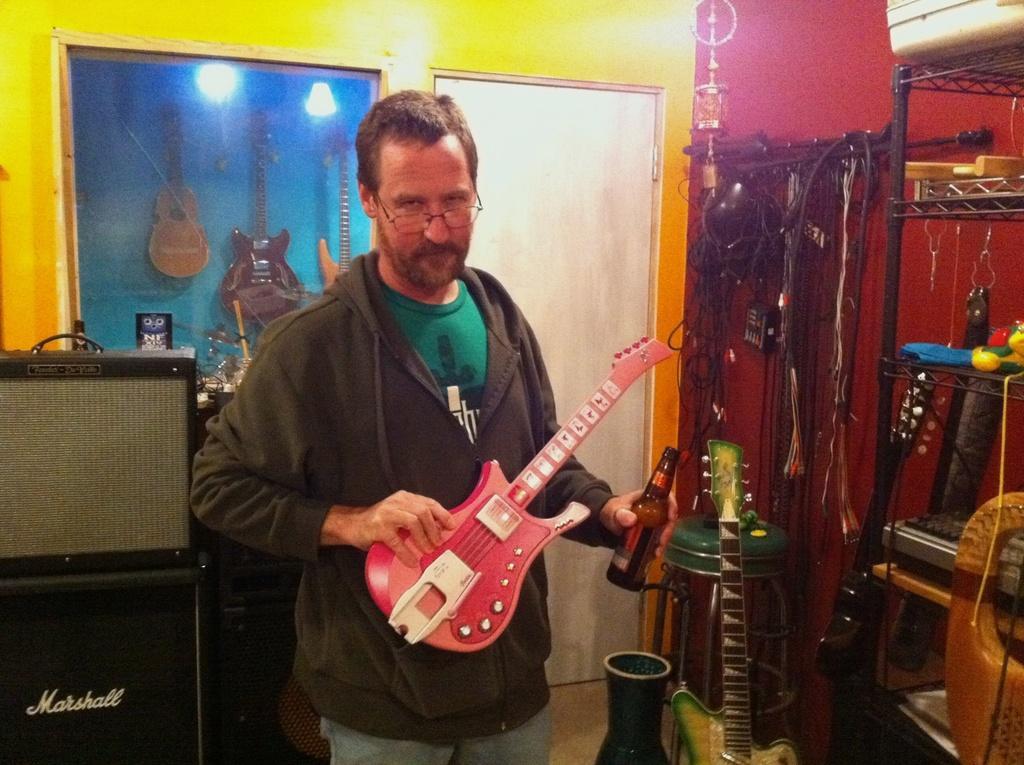In one or two sentences, can you explain what this image depicts? In the middle of the image a man is holding a guitar and a bottle. Bottom right side of the image there are some musical instruments. Bottom left side of the image there is a speaker. At the top of the image there is a wall and door. 